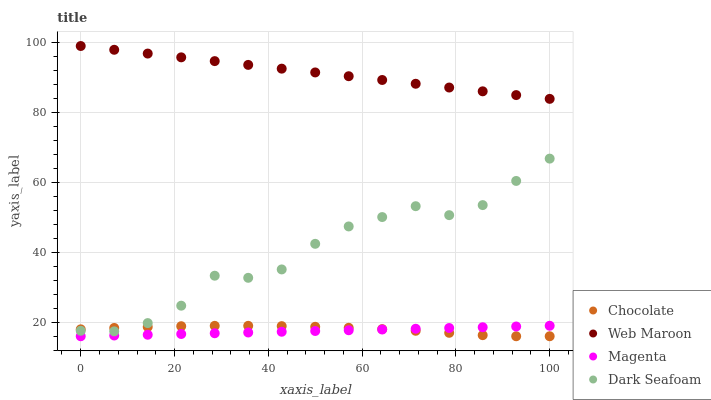Does Magenta have the minimum area under the curve?
Answer yes or no. Yes. Does Web Maroon have the maximum area under the curve?
Answer yes or no. Yes. Does Dark Seafoam have the minimum area under the curve?
Answer yes or no. No. Does Dark Seafoam have the maximum area under the curve?
Answer yes or no. No. Is Magenta the smoothest?
Answer yes or no. Yes. Is Dark Seafoam the roughest?
Answer yes or no. Yes. Is Web Maroon the smoothest?
Answer yes or no. No. Is Web Maroon the roughest?
Answer yes or no. No. Does Magenta have the lowest value?
Answer yes or no. Yes. Does Dark Seafoam have the lowest value?
Answer yes or no. No. Does Web Maroon have the highest value?
Answer yes or no. Yes. Does Dark Seafoam have the highest value?
Answer yes or no. No. Is Chocolate less than Web Maroon?
Answer yes or no. Yes. Is Dark Seafoam greater than Magenta?
Answer yes or no. Yes. Does Chocolate intersect Dark Seafoam?
Answer yes or no. Yes. Is Chocolate less than Dark Seafoam?
Answer yes or no. No. Is Chocolate greater than Dark Seafoam?
Answer yes or no. No. Does Chocolate intersect Web Maroon?
Answer yes or no. No. 